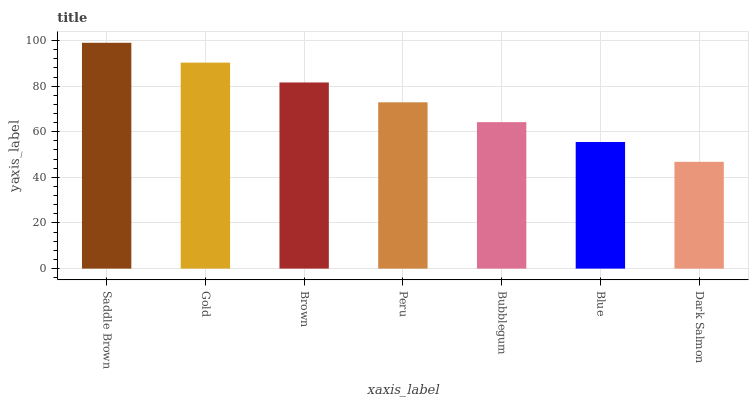Is Dark Salmon the minimum?
Answer yes or no. Yes. Is Saddle Brown the maximum?
Answer yes or no. Yes. Is Gold the minimum?
Answer yes or no. No. Is Gold the maximum?
Answer yes or no. No. Is Saddle Brown greater than Gold?
Answer yes or no. Yes. Is Gold less than Saddle Brown?
Answer yes or no. Yes. Is Gold greater than Saddle Brown?
Answer yes or no. No. Is Saddle Brown less than Gold?
Answer yes or no. No. Is Peru the high median?
Answer yes or no. Yes. Is Peru the low median?
Answer yes or no. Yes. Is Gold the high median?
Answer yes or no. No. Is Gold the low median?
Answer yes or no. No. 